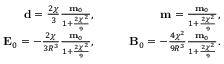<formula> <loc_0><loc_0><loc_500><loc_500>\begin{array} { r l r } { d = \frac { 2 \chi } { 3 } \frac { m _ { 0 } } { 1 + \frac { 2 \chi ^ { 2 } } { 9 } } , } & { \quad } & { m = \frac { m _ { 0 } } { 1 + \frac { 2 \chi ^ { 2 } } { 9 } } , } \\ { E _ { 0 } = - \frac { 2 \chi } { 3 R ^ { 3 } } \frac { m _ { 0 } } { 1 + \frac { 2 \chi ^ { 2 } } { 9 } } , } & { \quad } & { B _ { 0 } = - \frac { 4 \chi ^ { 2 } } { 9 R ^ { 3 } } \frac { m _ { 0 } } { 1 + \frac { 2 \chi ^ { 2 } } { 9 } } . } \end{array}</formula> 